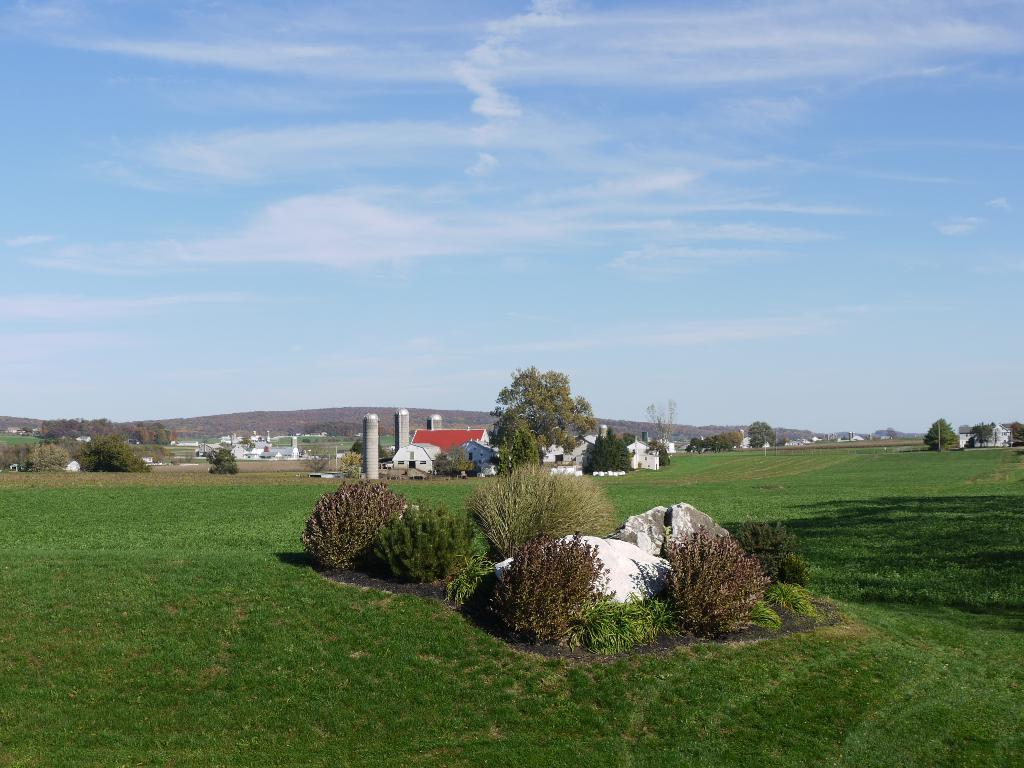What type of vegetation can be seen in the image? There is grass, bushes, and trees in the image. What type of natural features are present in the image? There are stones and mountains in the image. What type of man-made structures are present in the image? There are buildings in the image. What is visible in the background of the image? There are mountains in the background of the image. What part of the natural environment is visible in the image? The sky is visible in the image. What type of coast can be seen in the image? There is no coast present in the image. What type of crib is visible in the image? There is no crib present in the image. 